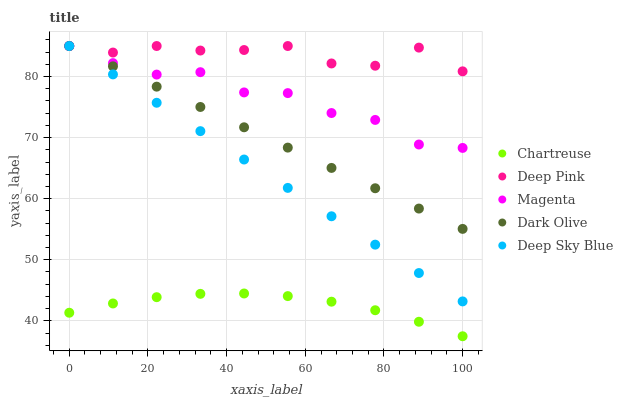Does Chartreuse have the minimum area under the curve?
Answer yes or no. Yes. Does Deep Pink have the maximum area under the curve?
Answer yes or no. Yes. Does Deep Pink have the minimum area under the curve?
Answer yes or no. No. Does Chartreuse have the maximum area under the curve?
Answer yes or no. No. Is Deep Sky Blue the smoothest?
Answer yes or no. Yes. Is Magenta the roughest?
Answer yes or no. Yes. Is Chartreuse the smoothest?
Answer yes or no. No. Is Chartreuse the roughest?
Answer yes or no. No. Does Chartreuse have the lowest value?
Answer yes or no. Yes. Does Deep Pink have the lowest value?
Answer yes or no. No. Does Deep Sky Blue have the highest value?
Answer yes or no. Yes. Does Chartreuse have the highest value?
Answer yes or no. No. Is Chartreuse less than Deep Pink?
Answer yes or no. Yes. Is Dark Olive greater than Chartreuse?
Answer yes or no. Yes. Does Magenta intersect Deep Pink?
Answer yes or no. Yes. Is Magenta less than Deep Pink?
Answer yes or no. No. Is Magenta greater than Deep Pink?
Answer yes or no. No. Does Chartreuse intersect Deep Pink?
Answer yes or no. No. 